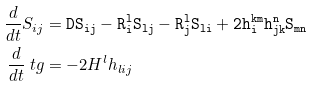<formula> <loc_0><loc_0><loc_500><loc_500>\frac { d } { d t } S _ { i j } & = \tt D S _ { i j } - R ^ { l } _ { i } S _ { l j } - R ^ { l } _ { j } S _ { l i } + 2 h ^ { k m } _ { i } h ^ { n } _ { j k } S _ { m n } \\ \frac { d } { d t } \ t g & = - 2 H ^ { l } h _ { l i j }</formula> 